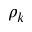Convert formula to latex. <formula><loc_0><loc_0><loc_500><loc_500>\rho _ { k }</formula> 